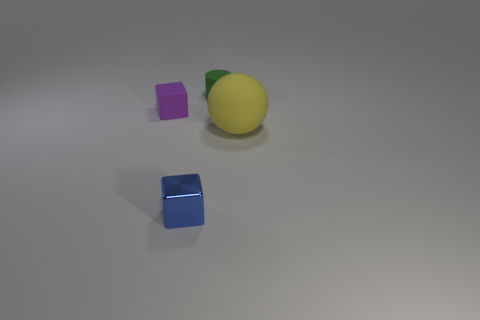What time of day does the lighting in the scene suggest? The lighting in the image is diffuse, lacking strong shadows or highlights that would indicate a particular time of day. It seems more like artificial, studio lighting used for neutral illumination, so it doesn't specifically suggest any time of day. 